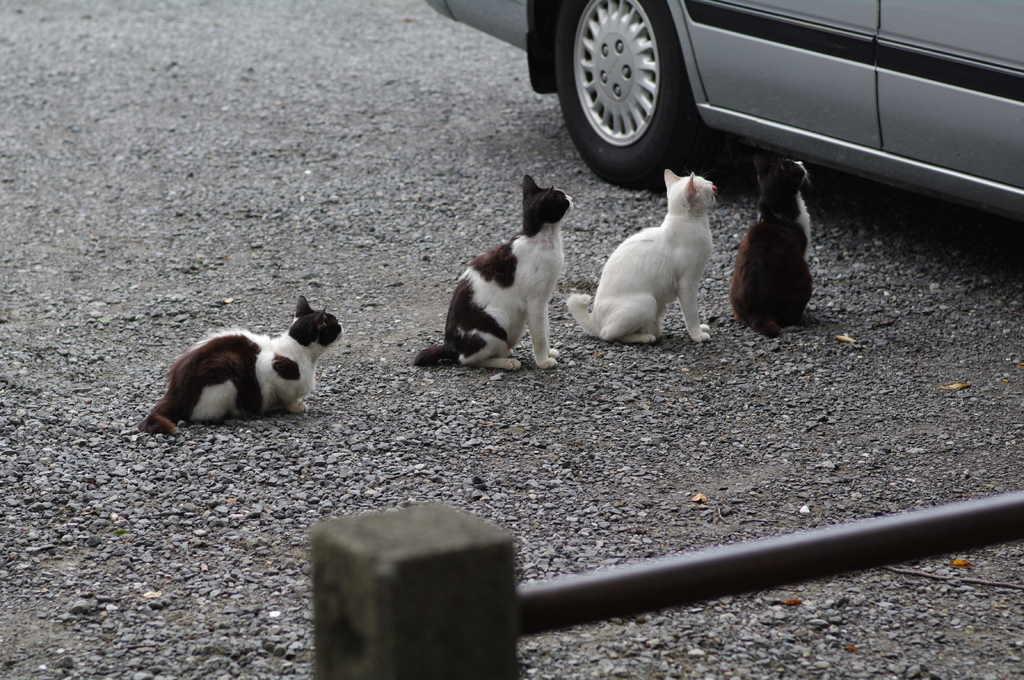Could you give a brief overview of what you see in this image? In this image we can see some cats on the ground. We can also see some stones, a car and a metal pole. 